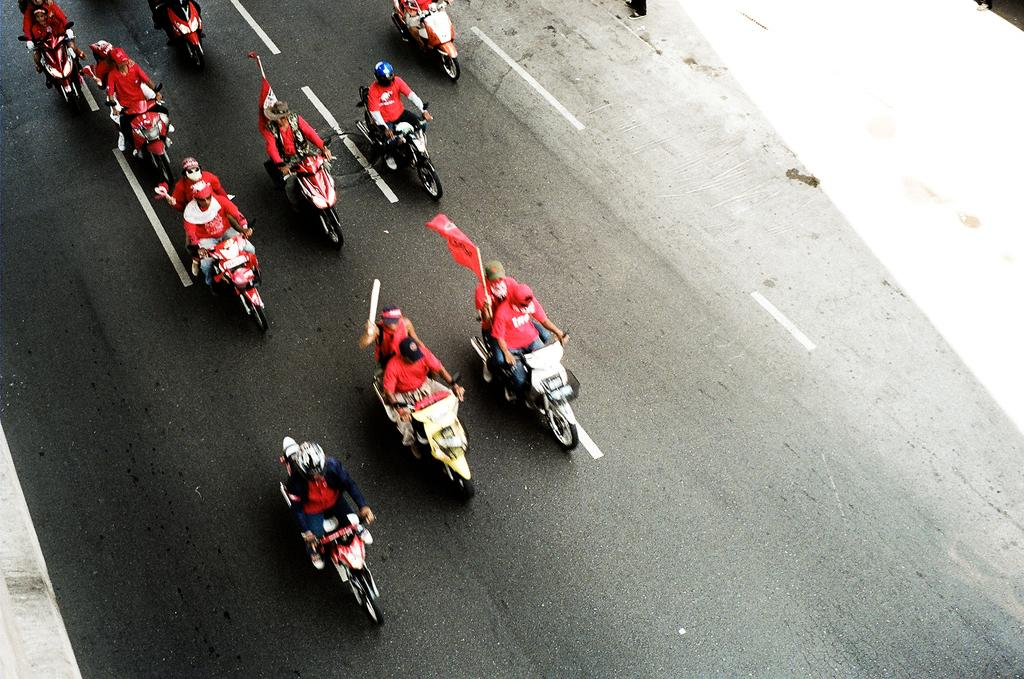What are the people in the image doing? The people in the image are riding bikes. What are the people wearing while riding bikes? The people are wearing red dresses. What can be seen in the middle of the road in the image? There is a man in the center of the road. What is the man holding in the image? The man is holding a flag. What type of drum can be heard playing in the image? There is no drum present or audible in the image. 